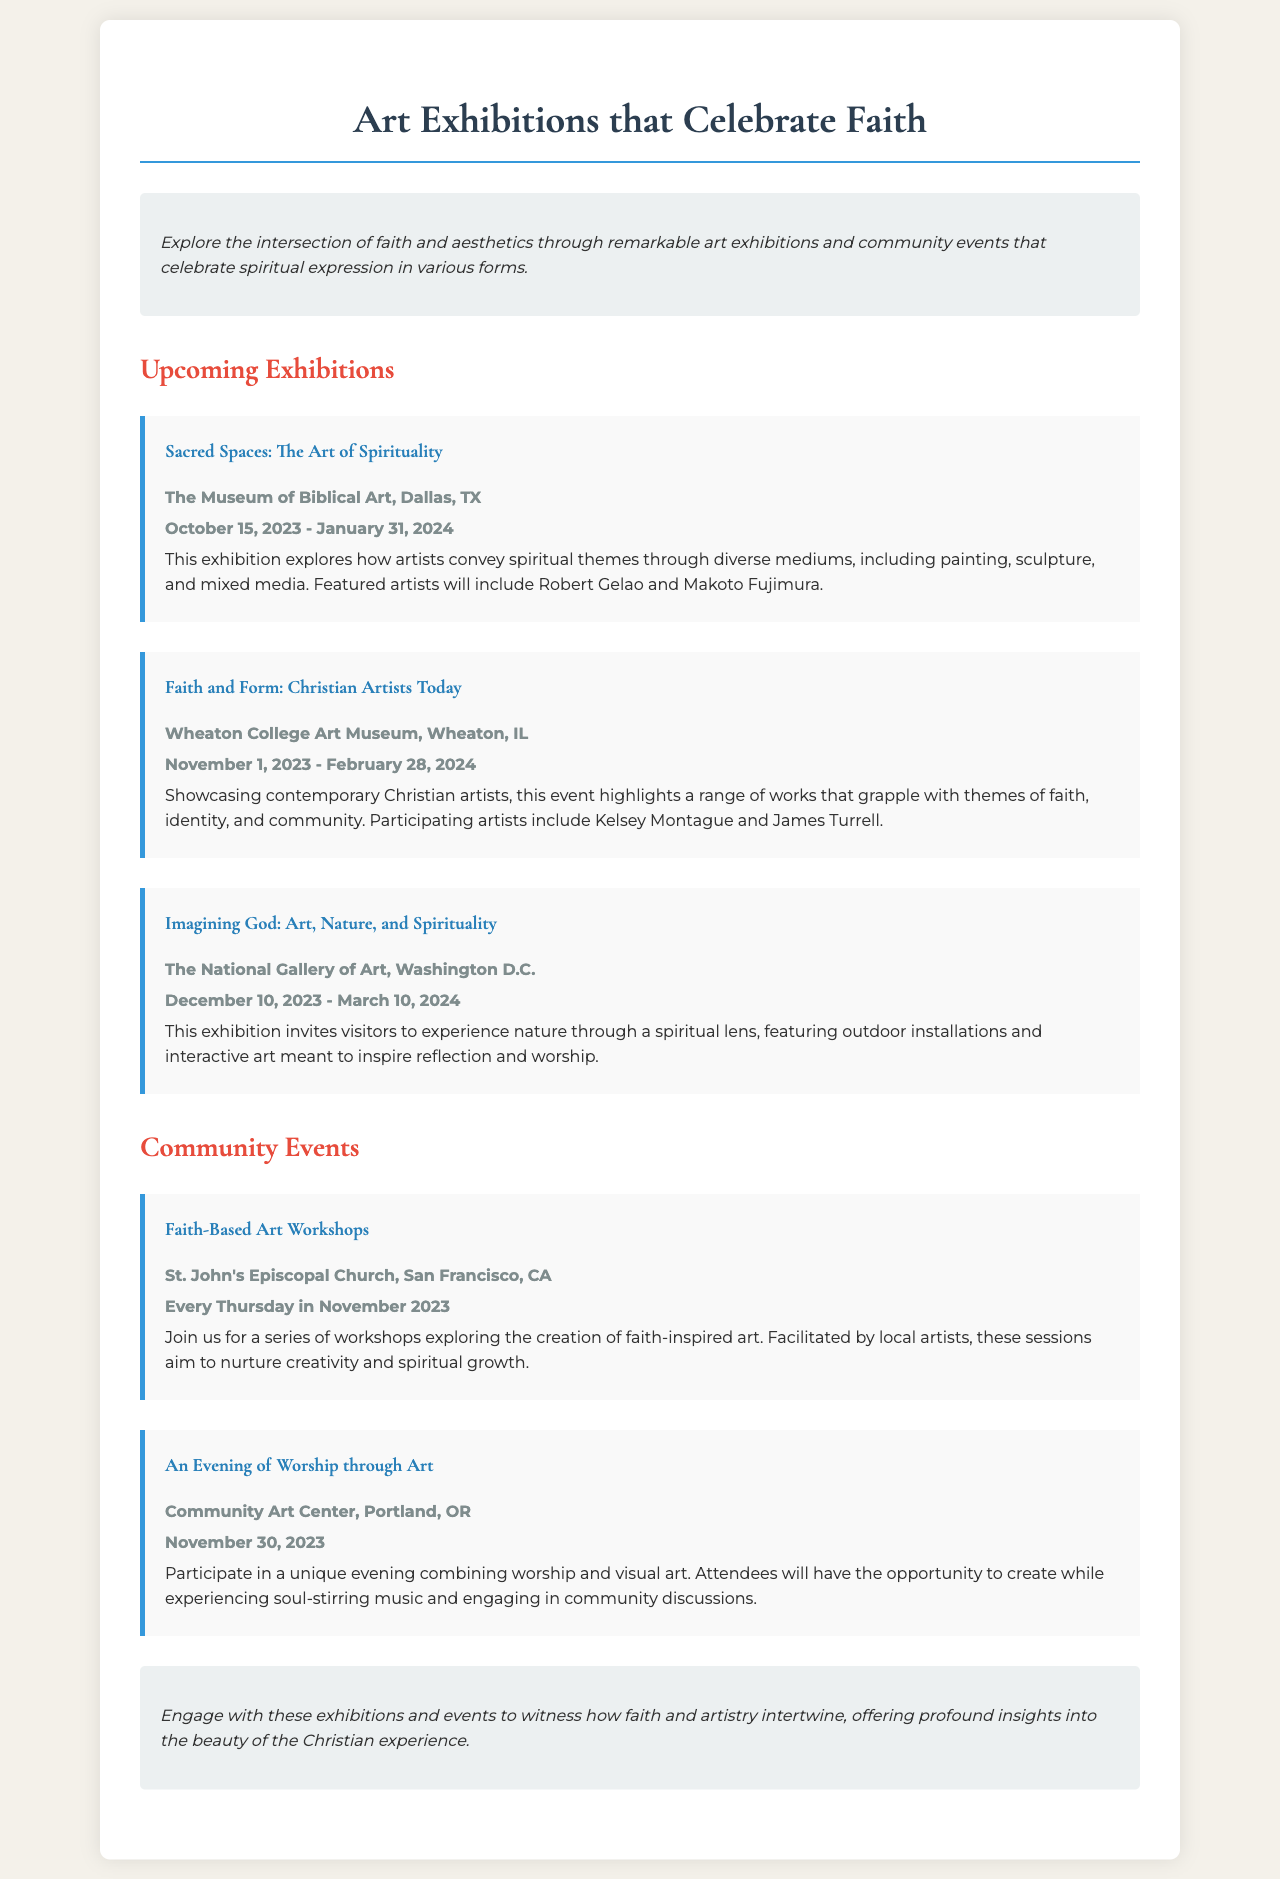What is the title of the first exhibition? The title is mentioned in the section about Upcoming Exhibitions, specifically highlighting the first event listed.
Answer: Sacred Spaces: The Art of Spirituality Where will the Faith and Form exhibition take place? The location is specified alongside the dates for this specific event in the Upcoming Exhibitions section.
Answer: Wheaton College Art Museum, Wheaton, IL What is the start date for Imagining God exhibition? The start date is provided in the details of the event listed in the document.
Answer: December 10, 2023 How many community events are listed in the document? The number of community events can be counted from the Community Events section, where each event is described.
Answer: 2 What theme does the exhibition Sacred Spaces explore? The theme is described in the context of what the exhibition conveys artistically, as detailed in the document.
Answer: Spirituality When will the Faith-Based Art Workshops occur? The specific days are detailed in the Community Events section related to this particular workshop.
Answer: Every Thursday in November 2023 Who are two featured artists in the exhibition Sacred Spaces? The document lists the names of the featured artists as part of the exhibition description.
Answer: Robert Gelao and Makoto Fujimura What type of event is An Evening of Worship through Art? The type of event is categorized and described in its title, along with details provided within the Community Events section.
Answer: Worship through Art 